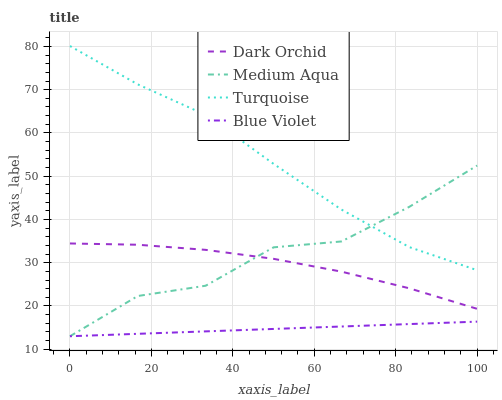Does Blue Violet have the minimum area under the curve?
Answer yes or no. Yes. Does Turquoise have the maximum area under the curve?
Answer yes or no. Yes. Does Medium Aqua have the minimum area under the curve?
Answer yes or no. No. Does Medium Aqua have the maximum area under the curve?
Answer yes or no. No. Is Blue Violet the smoothest?
Answer yes or no. Yes. Is Medium Aqua the roughest?
Answer yes or no. Yes. Is Medium Aqua the smoothest?
Answer yes or no. No. Is Blue Violet the roughest?
Answer yes or no. No. Does Medium Aqua have the lowest value?
Answer yes or no. Yes. Does Dark Orchid have the lowest value?
Answer yes or no. No. Does Turquoise have the highest value?
Answer yes or no. Yes. Does Medium Aqua have the highest value?
Answer yes or no. No. Is Blue Violet less than Turquoise?
Answer yes or no. Yes. Is Dark Orchid greater than Blue Violet?
Answer yes or no. Yes. Does Turquoise intersect Medium Aqua?
Answer yes or no. Yes. Is Turquoise less than Medium Aqua?
Answer yes or no. No. Is Turquoise greater than Medium Aqua?
Answer yes or no. No. Does Blue Violet intersect Turquoise?
Answer yes or no. No. 